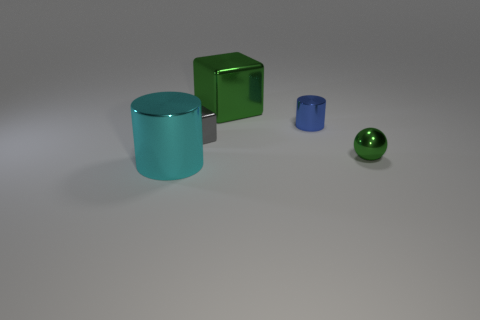There is a large cube; is it the same color as the small metallic object in front of the gray metal thing?
Keep it short and to the point. Yes. What is the shape of the metal thing on the left side of the gray metal thing?
Your answer should be compact. Cylinder. What number of other things are made of the same material as the big green object?
Ensure brevity in your answer.  4. What is the material of the gray block?
Your answer should be very brief. Metal. What number of large objects are gray blocks or purple matte spheres?
Give a very brief answer. 0. There is a blue cylinder; how many big cyan metal cylinders are in front of it?
Give a very brief answer. 1. Is there a block of the same color as the ball?
Offer a very short reply. Yes. There is a green thing that is the same size as the blue shiny cylinder; what shape is it?
Give a very brief answer. Sphere. What number of gray objects are either big matte blocks or small blocks?
Your answer should be compact. 1. How many green blocks have the same size as the blue metal thing?
Offer a very short reply. 0. 